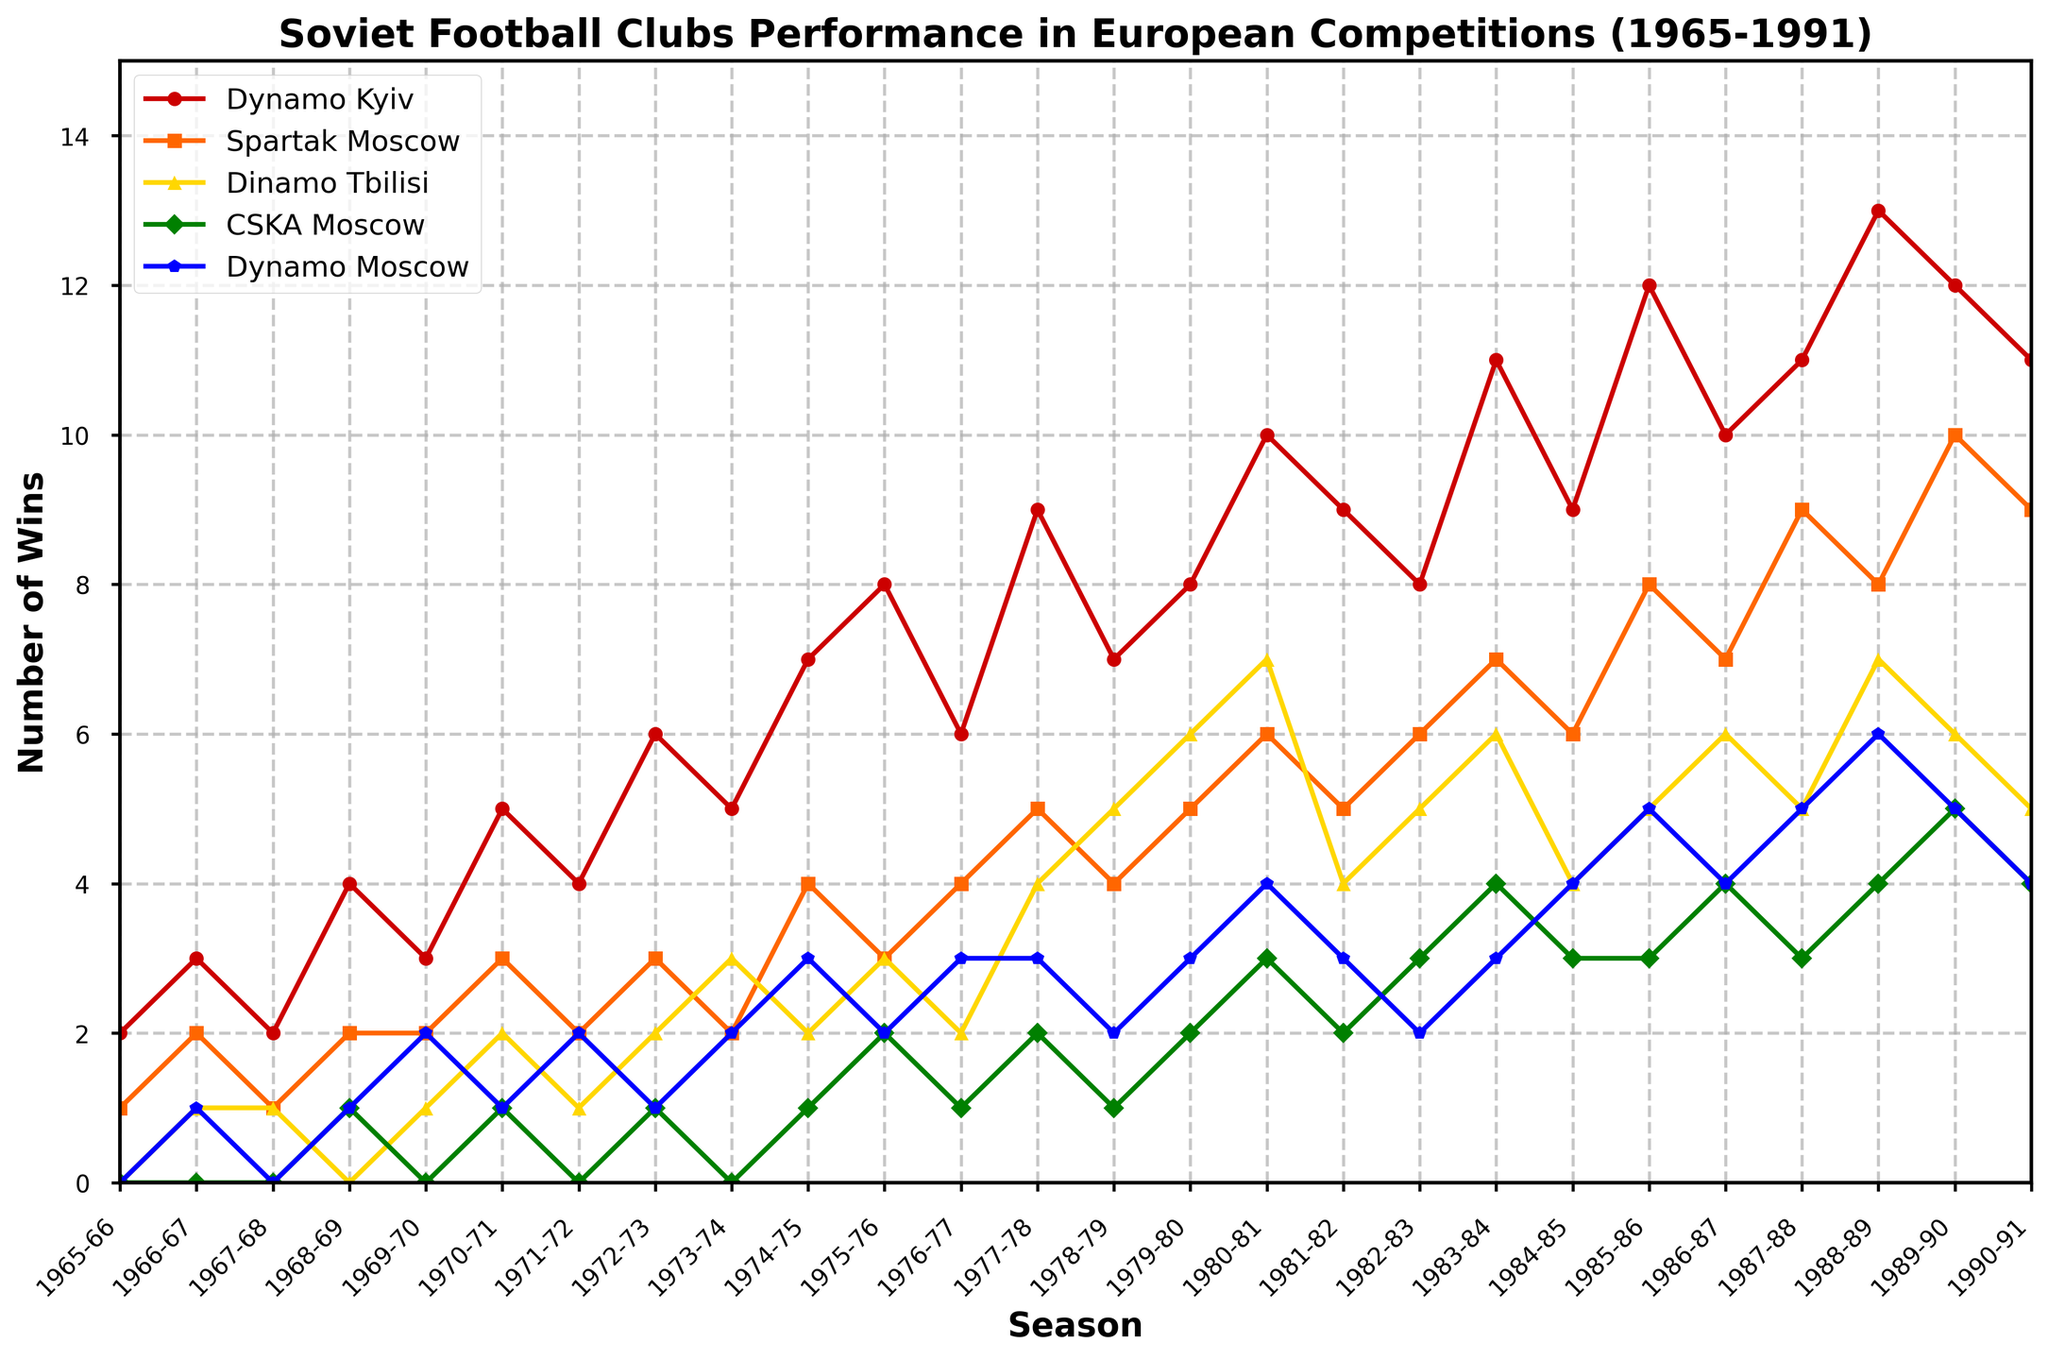Which club had the highest number of wins in the 1985-86 season? Look at the values for the 1985-86 season across all clubs. The club with the highest number of wins is Dynamo Kyiv with 12 wins.
Answer: Dynamo Kyiv In which seasons did Spartak Moscow win exactly 7 matches in European competitions? Check the plotted series for Spartak Moscow and see which seasons have 7 wins. These seasons are 1983-84 and 1986-87.
Answer: 1983-84, 1986-87 What is the average number of wins for Dinamo Tbilisi over the first five seasons? Summing up the wins for Dinamo Tbilisi from 1965-66 to 1969-70 (0+1+1+0+1) equals 3. The average is 3/5 = 0.6.
Answer: 0.6 How many more wins did Dynamo Kyiv have in the 1983-84 season than in the 1982-83 season? Dynamo Kyiv had 11 wins in 1983-84 and 8 wins in 1982-83. The difference is 11 - 8 = 3.
Answer: 3 Which club experienced the most fluctuations in performance over the entire period? By visually inspecting the plot and counting the peaks and drops, CSKA Moscow appears to have the most fluctuations with multiple seasons of zero wins mixed with occasional wins.
Answer: CSKA Moscow What’s the total number of wins for Dynamo Moscow over the entire period? Sum the values for Dynamo Moscow across all seasons from the table. Totaling all numbers gives a sum of 66 wins.
Answer: 66 Compare the number of wins between Dynamo Kyiv and Dinamo Tbilisi in the 1990-91 season. In the 1990-91 season, Dynamo Kyiv had 11 wins while Dinamo Tbilisi had 5.
Answer: Dynamo Kyiv had 6 more wins During which season did CSKA Moscow achieve its highest number of wins, and how many wins was that? Identify the peak value for CSKA Moscow in the plot. The highest number of wins is 5 in the 1989-90 season.
Answer: 1989-90, 5 What’s the combined number of wins for all clubs in the 1979-80 season? Add the number of wins for all clubs in the 1979-80 season: 8 (Dynamo Kyiv) + 5 (Spartak Moscow) + 6 (Dinamo Tbilisi) + 2 (CSKA Moscow) + 3 (Dynamo Moscow) = 24.
Answer: 24 How many seasons did Dynamo Kyiv have more than 10 wins? Count the number of seasons where Dynamo Kyiv’s wins exceed 10 by checking the plot: 1983-84, 1985-86, 1987-88, 1988-89, and 1989-90, total 5 seasons.
Answer: 5 